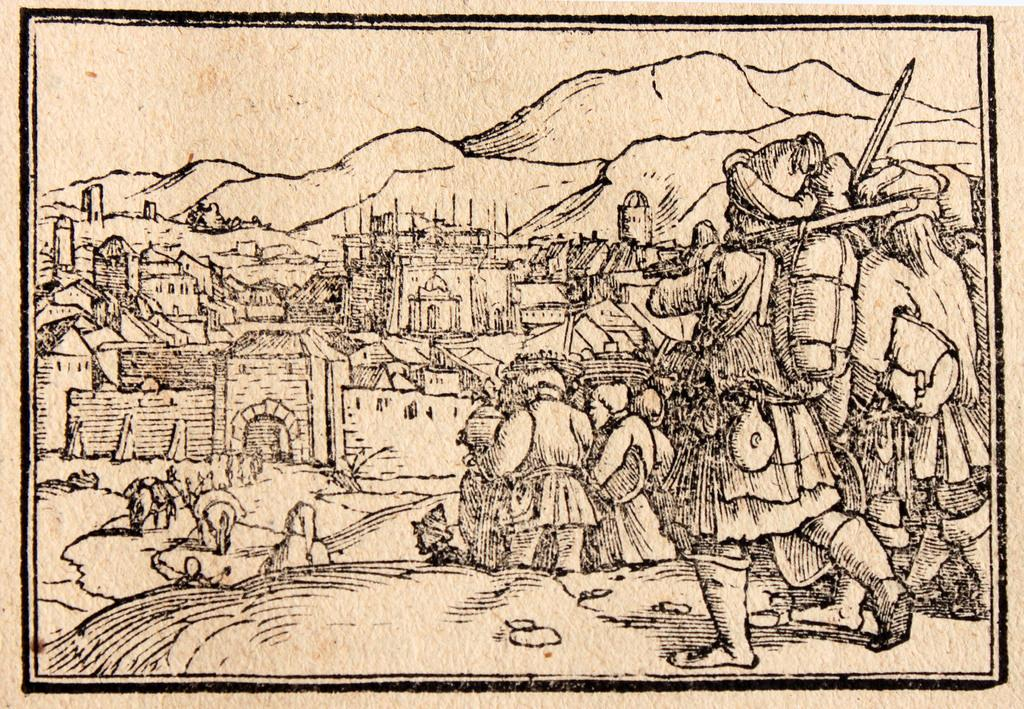What type of artwork is depicted in the image? The image is a drawing. What subjects are included in the drawing? There are persons, camels, buildings, and hills in the drawing. What part of the natural environment is visible in the drawing? Sky is visible in the drawing. What type of cap is the beef wearing in the drawing? There is no beef or cap present in the drawing; it features persons, camels, buildings, and hills. 